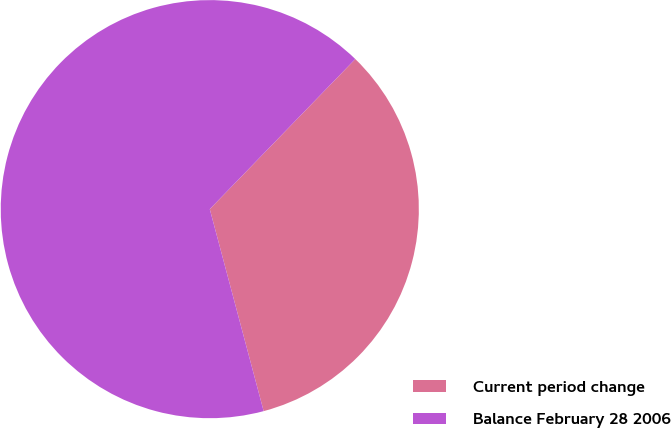Convert chart to OTSL. <chart><loc_0><loc_0><loc_500><loc_500><pie_chart><fcel>Current period change<fcel>Balance February 28 2006<nl><fcel>33.6%<fcel>66.4%<nl></chart> 